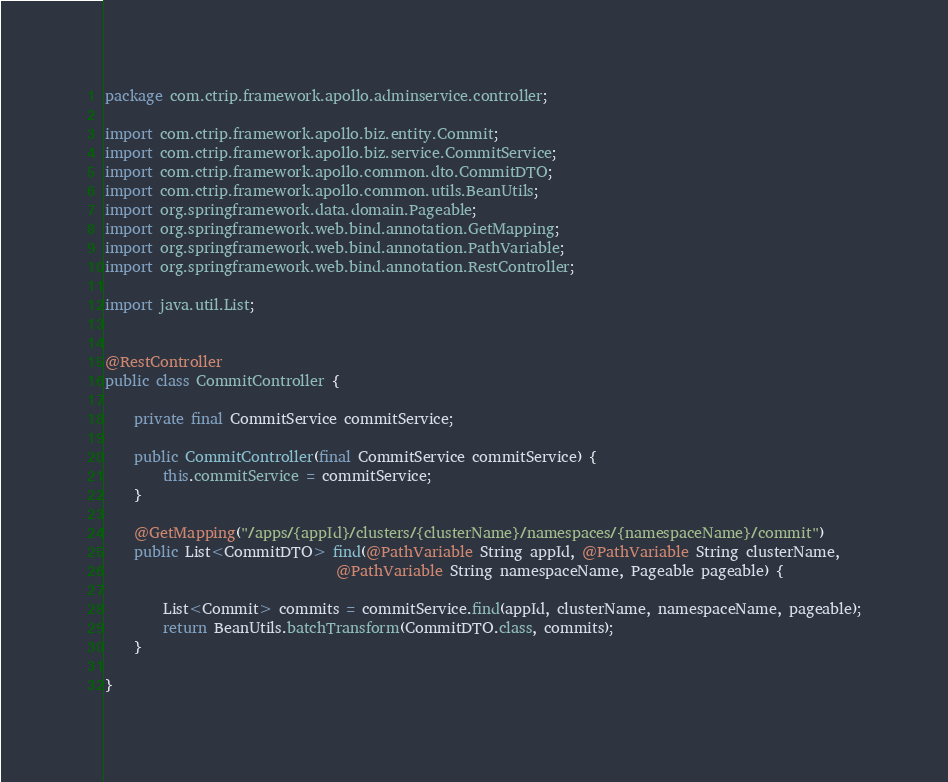<code> <loc_0><loc_0><loc_500><loc_500><_Java_>package com.ctrip.framework.apollo.adminservice.controller;

import com.ctrip.framework.apollo.biz.entity.Commit;
import com.ctrip.framework.apollo.biz.service.CommitService;
import com.ctrip.framework.apollo.common.dto.CommitDTO;
import com.ctrip.framework.apollo.common.utils.BeanUtils;
import org.springframework.data.domain.Pageable;
import org.springframework.web.bind.annotation.GetMapping;
import org.springframework.web.bind.annotation.PathVariable;
import org.springframework.web.bind.annotation.RestController;

import java.util.List;


@RestController
public class CommitController {

    private final CommitService commitService;

    public CommitController(final CommitService commitService) {
        this.commitService = commitService;
    }

    @GetMapping("/apps/{appId}/clusters/{clusterName}/namespaces/{namespaceName}/commit")
    public List<CommitDTO> find(@PathVariable String appId, @PathVariable String clusterName,
                                @PathVariable String namespaceName, Pageable pageable) {

        List<Commit> commits = commitService.find(appId, clusterName, namespaceName, pageable);
        return BeanUtils.batchTransform(CommitDTO.class, commits);
    }

}
</code> 